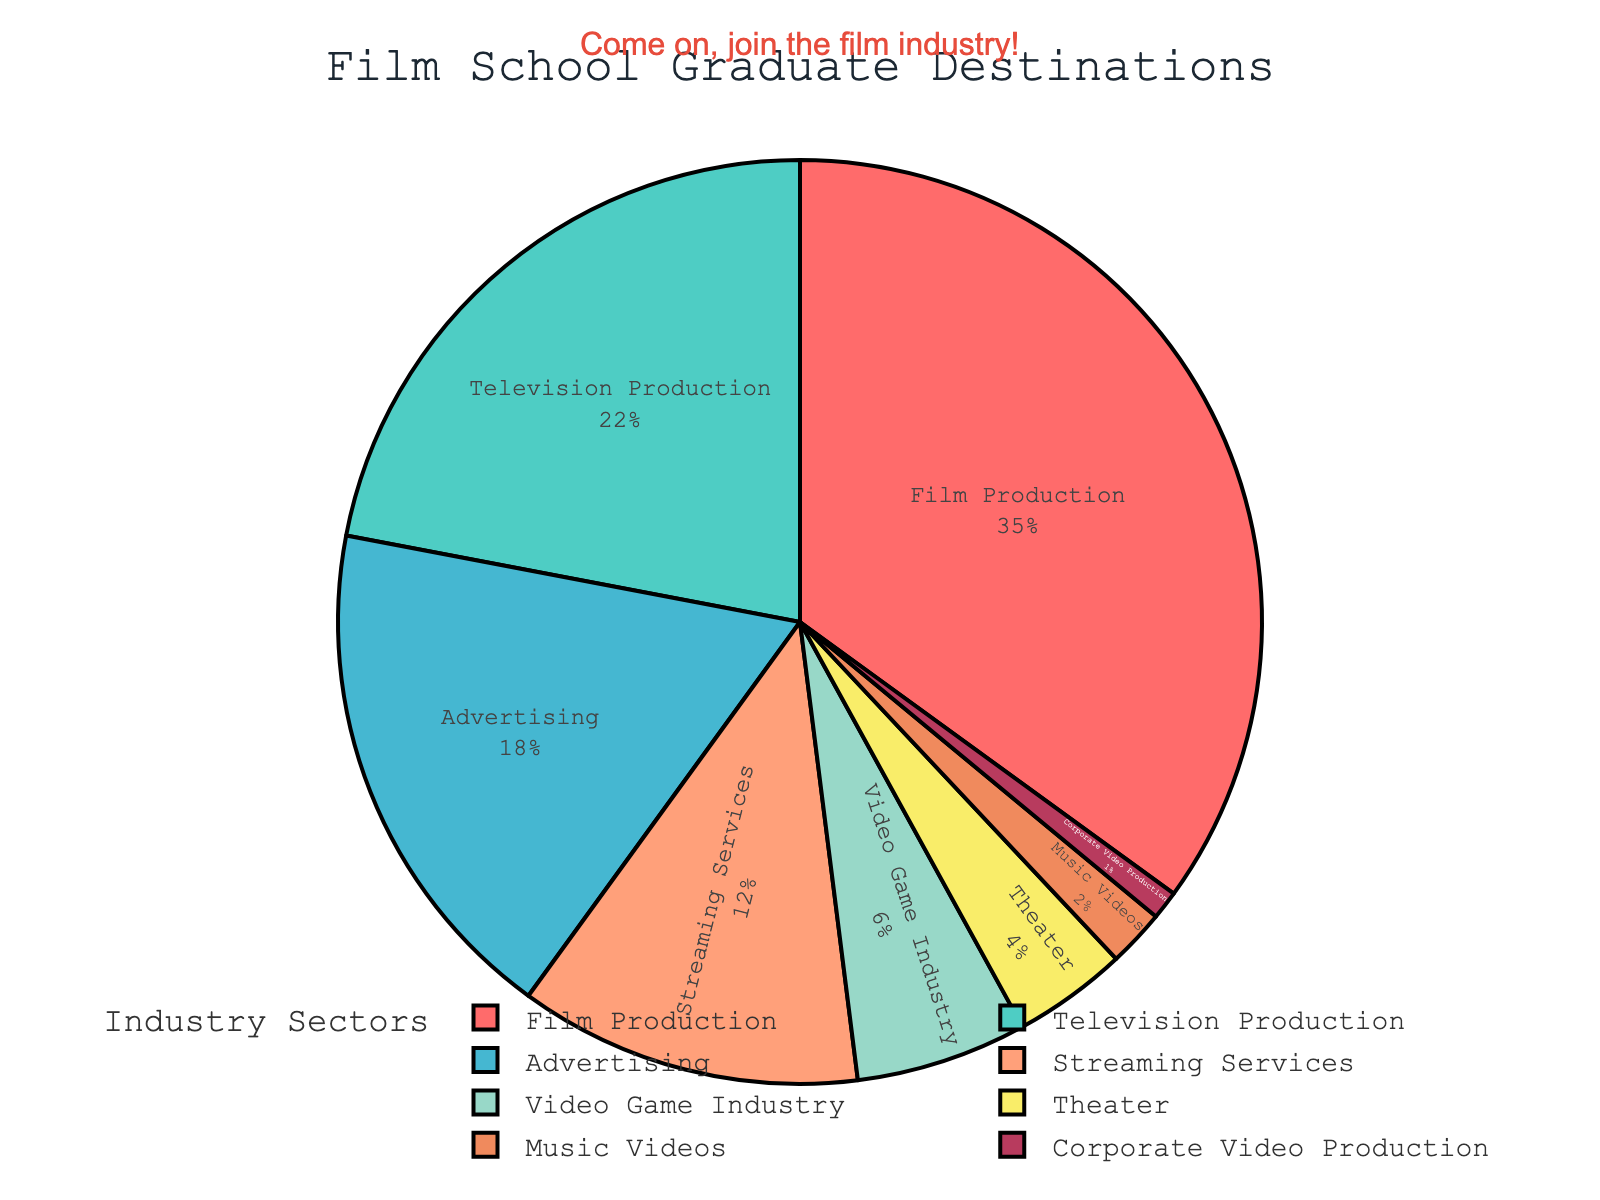what is the combined percentage of graduates working in Advertising and Television Production? Advertising has 18% and Television Production has 22%. Combined, it would be 18% + 22% = 40%.
Answer: 40% Which sector has the highest proportion of graduates? By looking at the pie chart, Film Production has the largest segment.
Answer: Film Production How much larger is the percentage of graduates in Streaming Services compared to Music Videos? Streaming Services occupies 12% and Music Videos occupy 2%. The difference is 12% - 2% = 10%.
Answer: 10% What percentage of graduates work in sectors other than Film Production and Television Production? First, we sum the percentages for Film Production (35%) and Television Production (22%), which gives 57%. The total percentage is 100%, so graduates working in other sectors would be 100% - 57% = 43%.
Answer: 43% Which two sectors combined have a smaller proportion of graduates than the Theater sector? The Theater sector has 4%. Both Music Videos (2%) and Corporate Video Production (1%) combined is 2% + 1% = 3%, which is smaller than Theater.
Answer: Music Videos and Corporate Video Production What is the combined share of the three smallest sectors? The smallest sectors are Corporate Video Production (1%), Music Videos (2%), and Theater (4%). Combined, their percentage is 1% + 2% + 4% = 7%.
Answer: 7% Which sectors have a smaller proportion of graduates than Advertising? Advertising has 18%. Sectors smaller are Streaming Services (12%), Video Game Industry (6%), Theater (4%), Music Videos (2%), and Corporate Video Production (1%).
Answer: Streaming Services, Video Game Industry, Theater, Music Videos, Corporate Video Production How much more likely are graduates to work in Film Production compared to the Video Game Industry? Film Production is at 35%, and Video Game Industry is at 6%. The difference is 35% - 6% = 29%.
Answer: 29% What color is the sector proportion for Film Production? Observing the pie chart, Film Production is represented by a red segment.
Answer: Red 